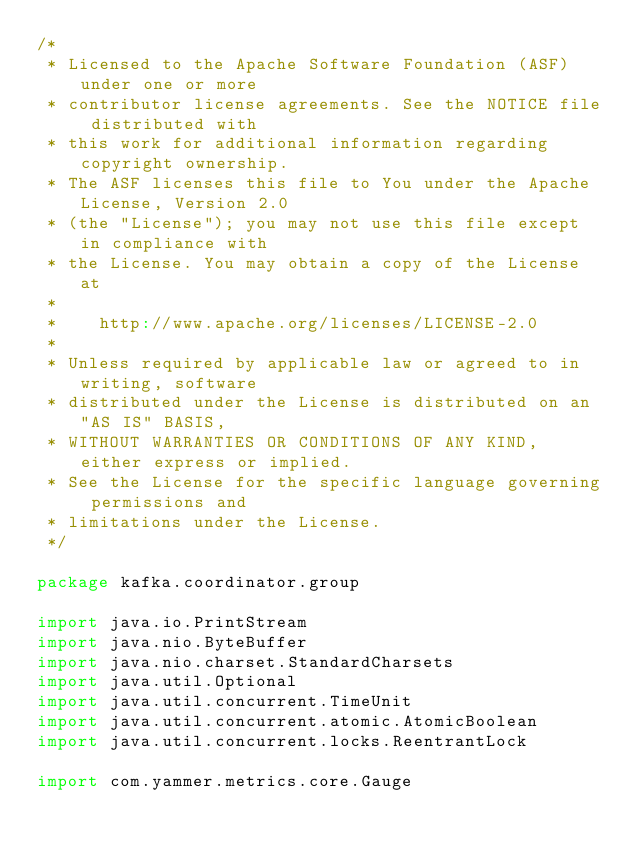<code> <loc_0><loc_0><loc_500><loc_500><_Scala_>/*
 * Licensed to the Apache Software Foundation (ASF) under one or more
 * contributor license agreements. See the NOTICE file distributed with
 * this work for additional information regarding copyright ownership.
 * The ASF licenses this file to You under the Apache License, Version 2.0
 * (the "License"); you may not use this file except in compliance with
 * the License. You may obtain a copy of the License at
 *
 *    http://www.apache.org/licenses/LICENSE-2.0
 *
 * Unless required by applicable law or agreed to in writing, software
 * distributed under the License is distributed on an "AS IS" BASIS,
 * WITHOUT WARRANTIES OR CONDITIONS OF ANY KIND, either express or implied.
 * See the License for the specific language governing permissions and
 * limitations under the License.
 */

package kafka.coordinator.group

import java.io.PrintStream
import java.nio.ByteBuffer
import java.nio.charset.StandardCharsets
import java.util.Optional
import java.util.concurrent.TimeUnit
import java.util.concurrent.atomic.AtomicBoolean
import java.util.concurrent.locks.ReentrantLock

import com.yammer.metrics.core.Gauge</code> 